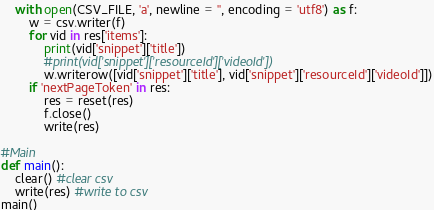<code> <loc_0><loc_0><loc_500><loc_500><_Python_>    with open(CSV_FILE, 'a', newline = '', encoding = 'utf8') as f:
        w = csv.writer(f)
        for vid in res['items']:
            print(vid['snippet']['title'])
            #print(vid['snippet']['resourceId']['videoId'])
            w.writerow([vid['snippet']['title'], vid['snippet']['resourceId']['videoId']])
        if 'nextPageToken' in res:
            res = reset(res)
            f.close()
            write(res)

#Main
def main():
    clear() #clear csv
    write(res) #write to csv
main()</code> 